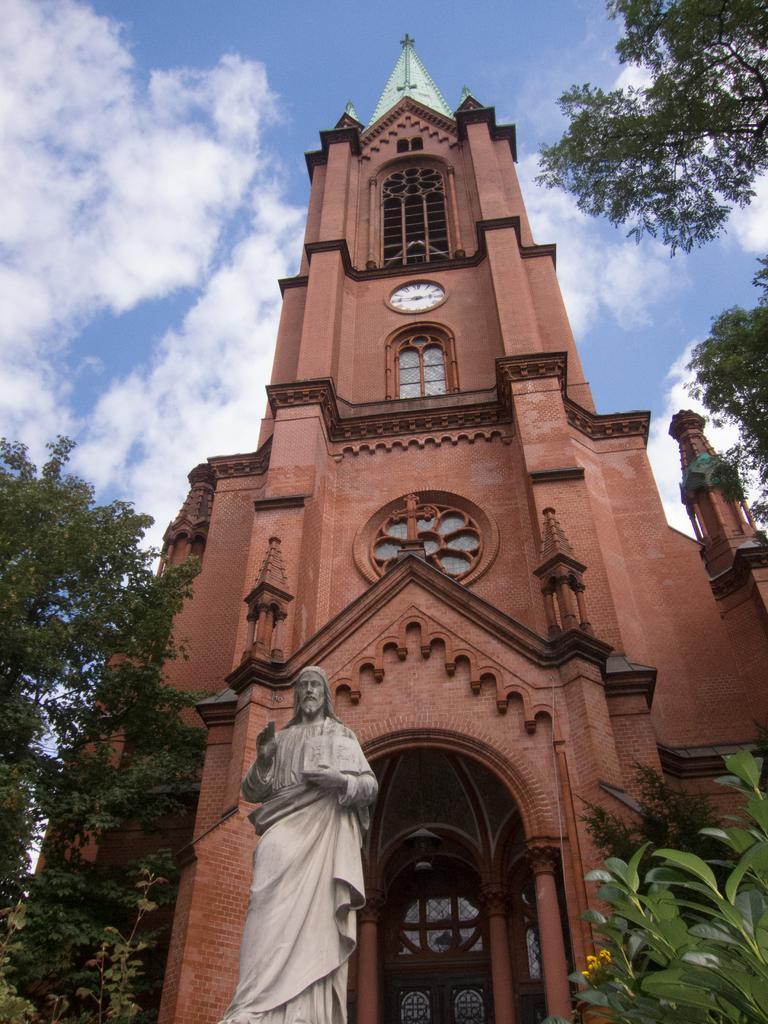Please provide a concise description of this image. In this picture we can observe a brown color building. We can observe a white color clock on the wall of this building. In front of this building there is a statue of Jesus. We can observe trees in this picture. In the background there is a sky with clouds. 